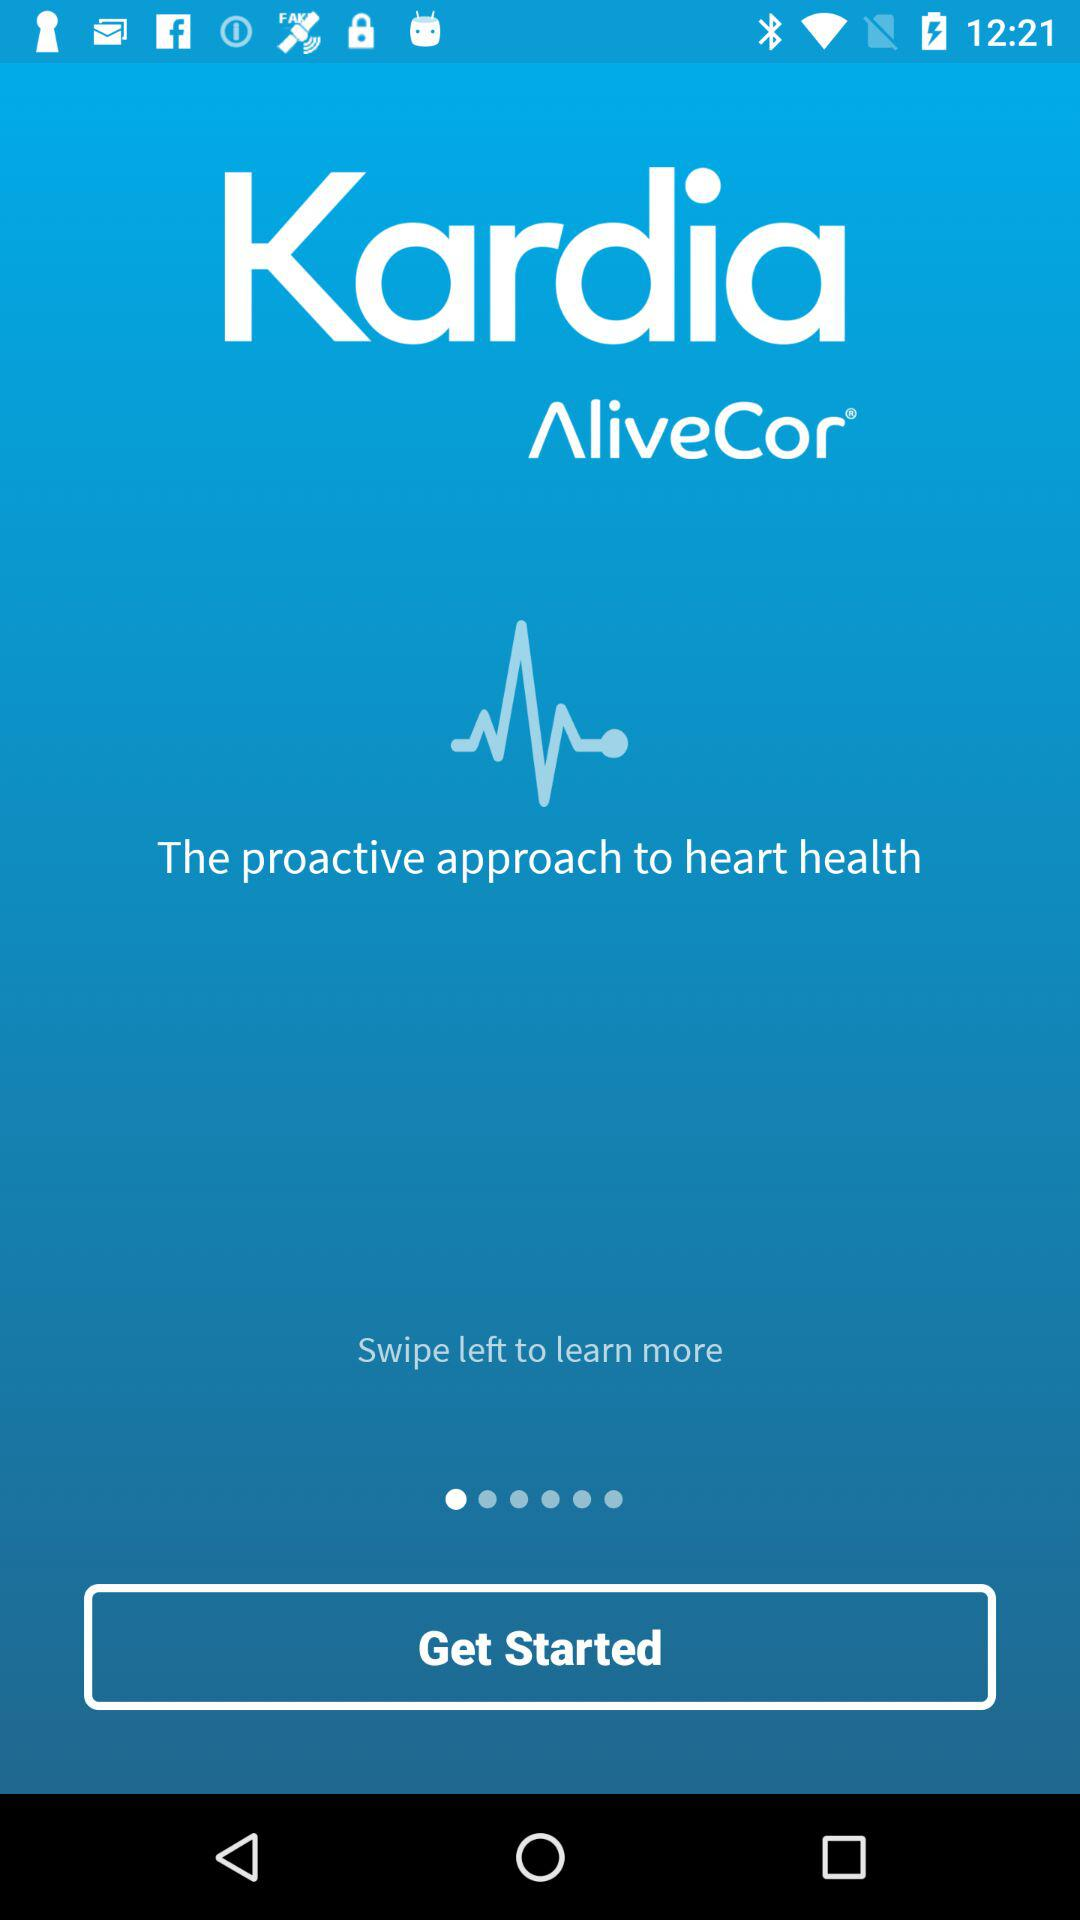What is the application name? The application name is "Kardia". 